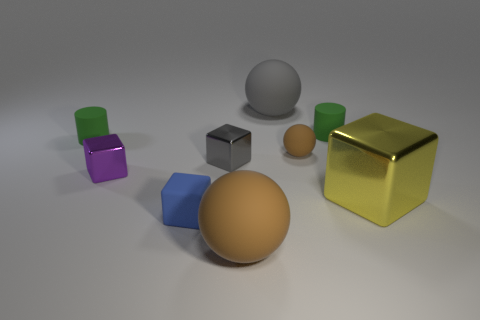Subtract 1 cubes. How many cubes are left? 3 Add 1 large yellow metallic blocks. How many objects exist? 10 Subtract all cylinders. How many objects are left? 7 Add 6 rubber balls. How many rubber balls are left? 9 Add 5 big green metal spheres. How many big green metal spheres exist? 5 Subtract 1 yellow cubes. How many objects are left? 8 Subtract all purple cylinders. Subtract all matte things. How many objects are left? 3 